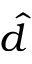Convert formula to latex. <formula><loc_0><loc_0><loc_500><loc_500>\hat { d }</formula> 